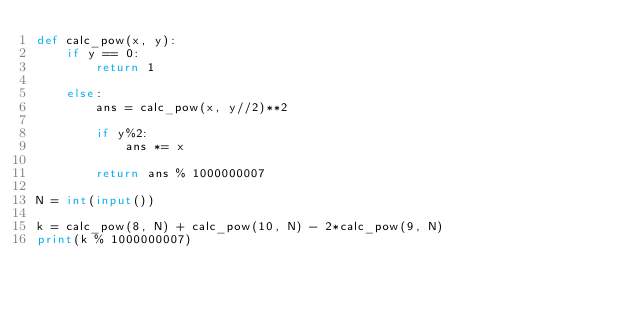Convert code to text. <code><loc_0><loc_0><loc_500><loc_500><_Python_>def calc_pow(x, y):
    if y == 0:
        return 1

    else:
        ans = calc_pow(x, y//2)**2

        if y%2:
            ans *= x
        
        return ans % 1000000007

N = int(input())

k = calc_pow(8, N) + calc_pow(10, N) - 2*calc_pow(9, N)
print(k % 1000000007)</code> 